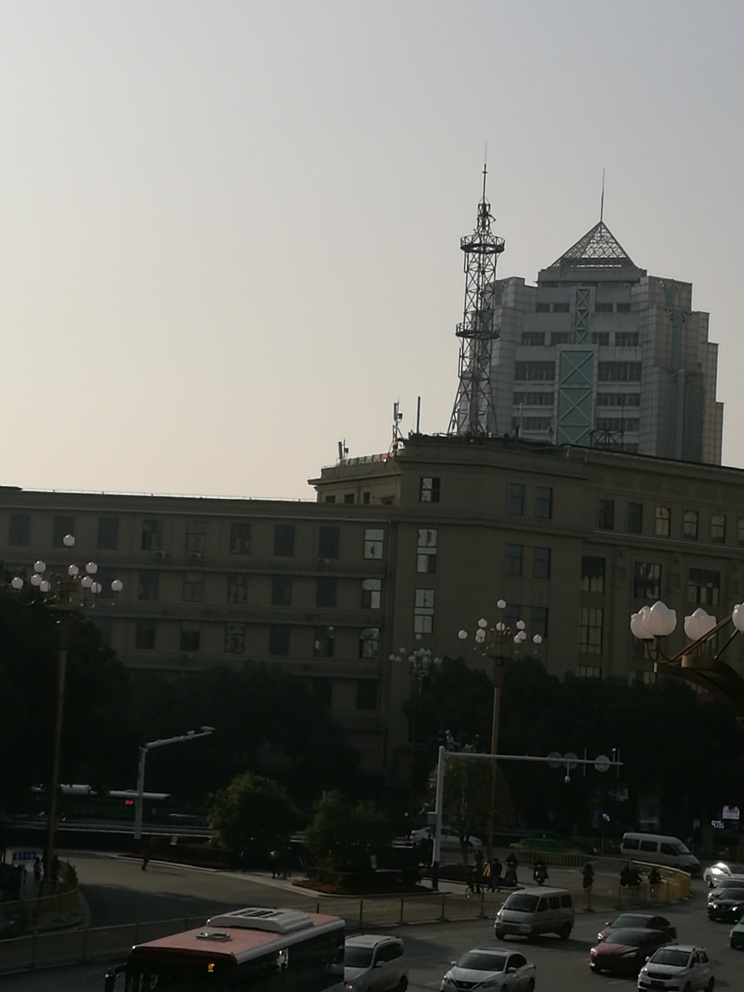What is the overall sharpness of the image? The sharpness of the image is moderately clear, but some areas appear slightly out of focus due to the lighting conditions, and details in shadows and highlights lack some definition. This could be a result of the camera settings used or the conditions at the time the photo was captured. Overall, the image's sharpness is acceptable but not optimal, capturing the urban scene with a fair level of detail. 